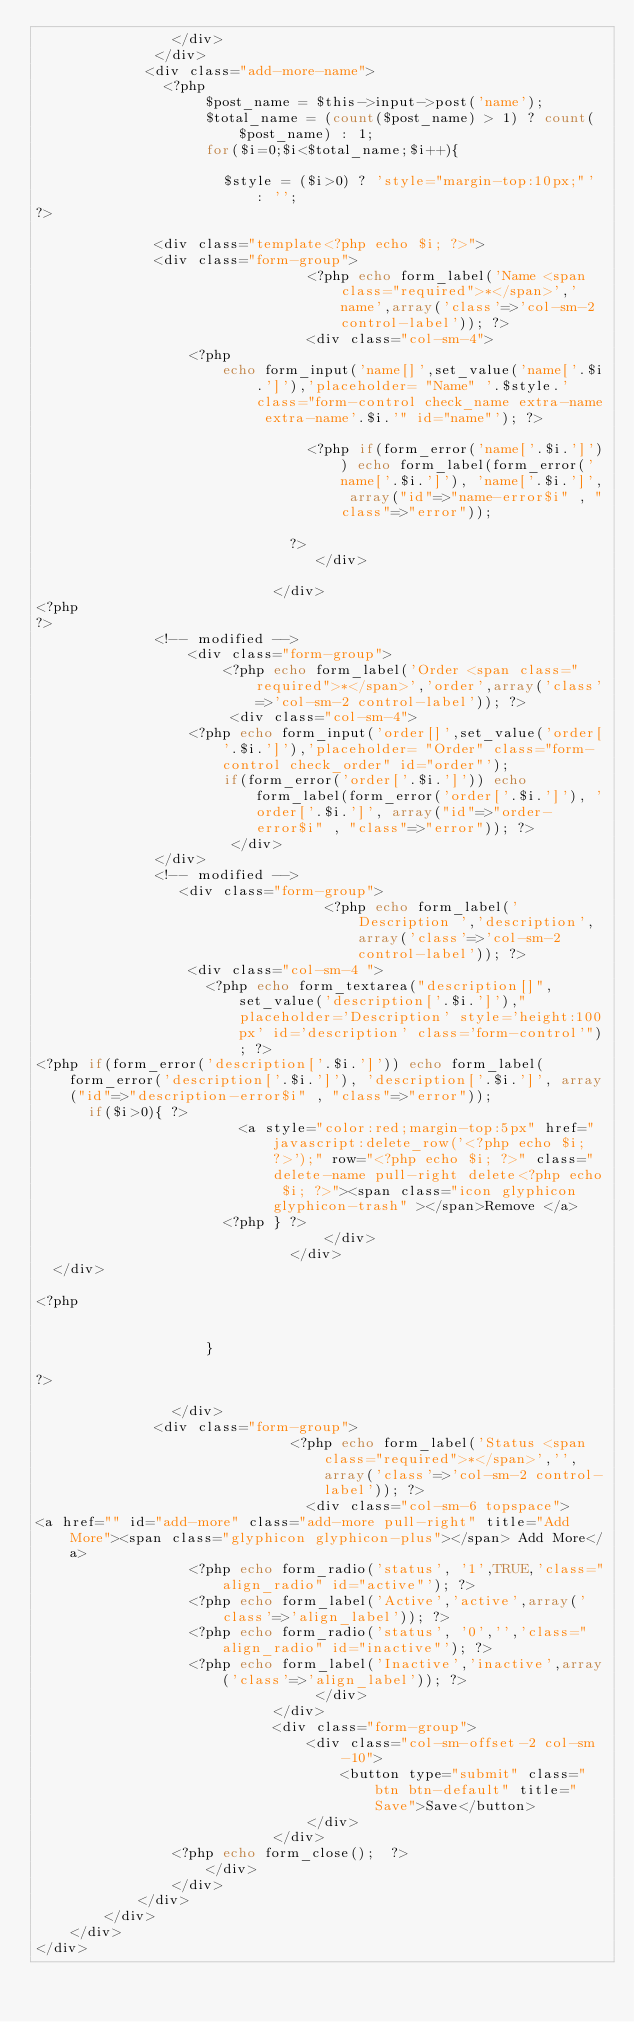Convert code to text. <code><loc_0><loc_0><loc_500><loc_500><_PHP_>								</div>
							</div>
						 <div class="add-more-name">
							 <?php 
										$post_name = $this->input->post('name');
										$total_name = (count($post_name) > 1) ? count($post_name) : 1;
										for($i=0;$i<$total_name;$i++){

											$style = ($i>0) ? 'style="margin-top:10px;"' : '';
?>
						
							<div class="template<?php echo $i; ?>">
							<div class="form-group">
                            		<?php echo form_label('Name <span class="required">*</span>','name',array('class'=>'col-sm-2 control-label')); ?>
                                <div class="col-sm-4">
									<?php
											echo form_input('name[]',set_value('name['.$i.']'),'placeholder= "Name" '.$style.' class="form-control check_name extra-name extra-name'.$i.'" id="name"'); ?> 
									
                   							<?php if(form_error('name['.$i.']')) echo form_label(form_error('name['.$i.']'), 'name['.$i.']', array("id"=>"name-error$i" , "class"=>"error"));
                   						
                   						?>
                                 </div>
                                 
                            </div>
<?php
?>
							<!-- modified -->
			            <div class="form-group">
	                  	<?php echo form_label('Order <span class="required">*</span>','order',array('class'=>'col-sm-2 control-label')); ?>
	                     <div class="col-sm-4">
									<?php echo form_input('order[]',set_value('order['.$i.']'),'placeholder= "Order" class="form-control check_order" id="order"'); 
	             				if(form_error('order['.$i.']')) echo form_label(form_error('order['.$i.']'), 'order['.$i.']', array("id"=>"order-error$i" , "class"=>"error")); ?>
	                     </div>
							</div>
							<!-- modified -->	
								 <div class="form-group">
                                	<?php echo form_label('Description ','description',array('class'=>'col-sm-2 control-label')); ?>
									<div class="col-sm-4 ">    
										<?php echo form_textarea("description[]",set_value('description['.$i.']'),"placeholder='Description' style='height:100px' id='description' class='form-control'"); ?> 
<?php if(form_error('description['.$i.']')) echo form_label(form_error('description['.$i.']'), 'description['.$i.']', array("id"=>"description-error$i" , "class"=>"error"));
		  if($i>0){ ?>
												<a style="color:red;margin-top:5px" href="javascript:delete_row('<?php echo $i; ?>');" row="<?php echo $i; ?>" class="delete-name pull-right delete<?php echo $i; ?>"><span class="icon glyphicon glyphicon-trash" ></span>Remove </a>
											<?php } ?>                                
                                	</div>
                            	</div>
	</div>

<?php


										} 
                   						
?>
						
								</div>
			 				<div class="form-group">
                            	<?php echo form_label('Status <span class="required">*</span>','',array('class'=>'col-sm-2 control-label')); ?>
                                <div class="col-sm-6 topspace">
<a href="" id="add-more" class="add-more pull-right" title="Add More"><span class="glyphicon glyphicon-plus"></span> Add More</a>
									<?php echo form_radio('status', '1',TRUE,'class="align_radio" id="active"'); ?> 
									<?php echo form_label('Active','active',array('class'=>'align_label')); ?>
									<?php echo form_radio('status', '0','','class="align_radio" id="inactive"'); ?> 
									<?php echo form_label('Inactive','inactive',array('class'=>'align_label')); ?>
                                 </div>
                            </div>
                            <div class="form-group">
                                <div class="col-sm-offset-2 col-sm-10">
                                    <button type="submit" class="btn btn-default" title="Save">Save</button>
                                </div>
                            </div>
								<?php echo form_close();  ?>
                    </div>
                </div>
            </div>
        </div>
    </div>
</div>


</code> 